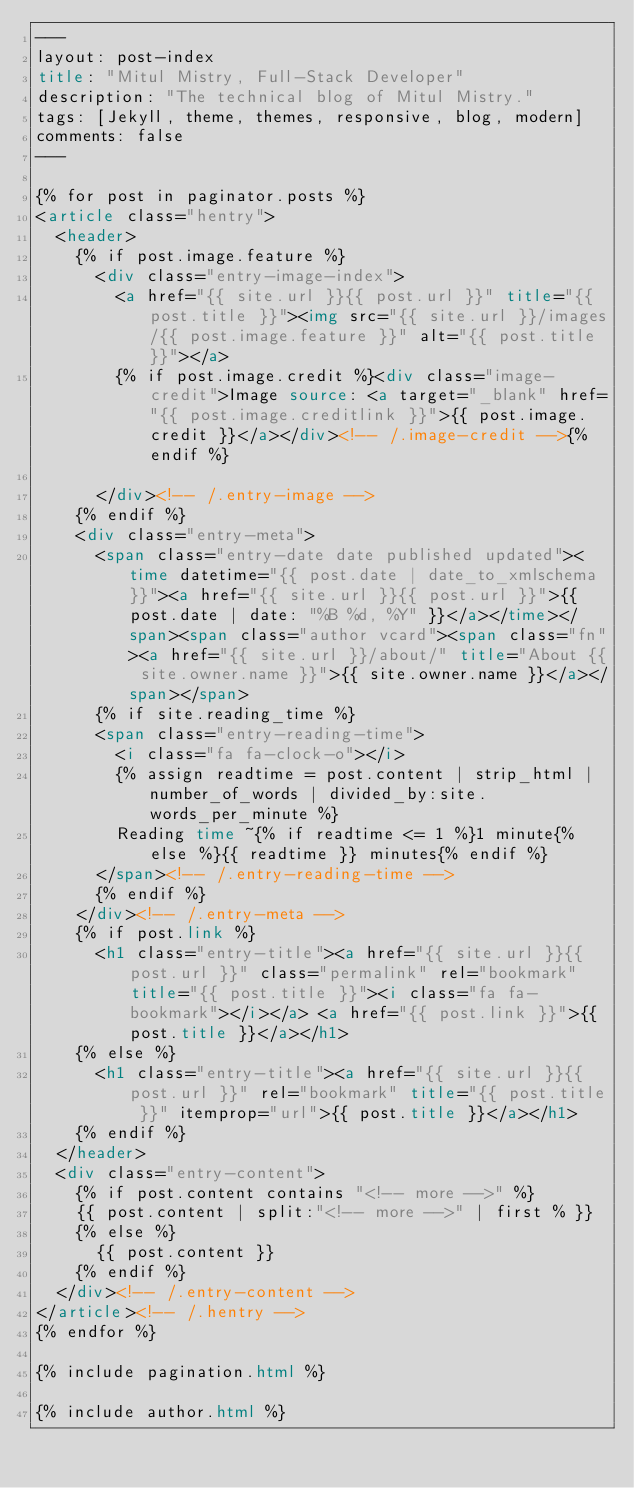<code> <loc_0><loc_0><loc_500><loc_500><_HTML_>---
layout: post-index
title: "Mitul Mistry, Full-Stack Developer"
description: "The technical blog of Mitul Mistry."
tags: [Jekyll, theme, themes, responsive, blog, modern]
comments: false
---

{% for post in paginator.posts %}
<article class="hentry">
  <header>
    {% if post.image.feature %}
      <div class="entry-image-index">
        <a href="{{ site.url }}{{ post.url }}" title="{{ post.title }}"><img src="{{ site.url }}/images/{{ post.image.feature }}" alt="{{ post.title }}"></a>
        {% if post.image.credit %}<div class="image-credit">Image source: <a target="_blank" href="{{ post.image.creditlink }}">{{ post.image.credit }}</a></div><!-- /.image-credit -->{% endif %}

      </div><!-- /.entry-image -->
    {% endif %}
    <div class="entry-meta">
      <span class="entry-date date published updated"><time datetime="{{ post.date | date_to_xmlschema }}"><a href="{{ site.url }}{{ post.url }}">{{ post.date | date: "%B %d, %Y" }}</a></time></span><span class="author vcard"><span class="fn"><a href="{{ site.url }}/about/" title="About {{ site.owner.name }}">{{ site.owner.name }}</a></span></span>
      {% if site.reading_time %}
      <span class="entry-reading-time">
        <i class="fa fa-clock-o"></i>
        {% assign readtime = post.content | strip_html | number_of_words | divided_by:site.words_per_minute %}
        Reading time ~{% if readtime <= 1 %}1 minute{% else %}{{ readtime }} minutes{% endif %}
      </span><!-- /.entry-reading-time -->
      {% endif %}
    </div><!-- /.entry-meta -->
    {% if post.link %}
      <h1 class="entry-title"><a href="{{ site.url }}{{ post.url }}" class="permalink" rel="bookmark" title="{{ post.title }}"><i class="fa fa-bookmark"></i></a> <a href="{{ post.link }}">{{ post.title }}</a></h1>
    {% else %}
      <h1 class="entry-title"><a href="{{ site.url }}{{ post.url }}" rel="bookmark" title="{{ post.title }}" itemprop="url">{{ post.title }}</a></h1>
    {% endif %}
  </header>
  <div class="entry-content">
    {% if post.content contains "<!-- more -->" %}
    {{ post.content | split:"<!-- more -->" | first % }}
    {% else %}
      {{ post.content }}
    {% endif %}
  </div><!-- /.entry-content -->
</article><!-- /.hentry -->
{% endfor %}

{% include pagination.html %}
  
{% include author.html %}
</code> 